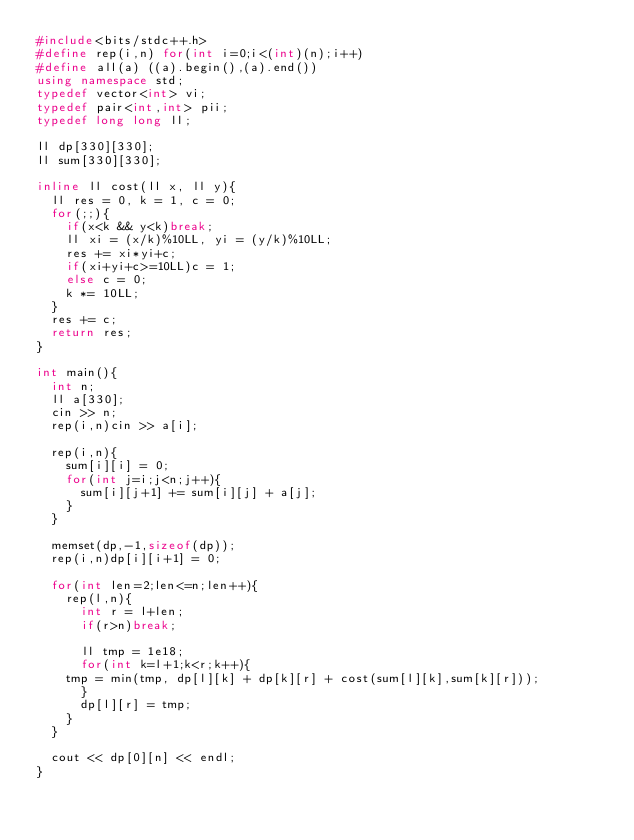<code> <loc_0><loc_0><loc_500><loc_500><_C++_>#include<bits/stdc++.h>
#define rep(i,n) for(int i=0;i<(int)(n);i++)
#define all(a) ((a).begin(),(a).end())
using namespace std;
typedef vector<int> vi;
typedef pair<int,int> pii;
typedef long long ll;

ll dp[330][330];
ll sum[330][330];

inline ll cost(ll x, ll y){
  ll res = 0, k = 1, c = 0;
  for(;;){
    if(x<k && y<k)break;
    ll xi = (x/k)%10LL, yi = (y/k)%10LL;
    res += xi*yi+c;
    if(xi+yi+c>=10LL)c = 1;
    else c = 0;
    k *= 10LL;
  }
  res += c;
  return res;
}

int main(){
  int n;
  ll a[330];
  cin >> n;
  rep(i,n)cin >> a[i];
  
  rep(i,n){
    sum[i][i] = 0;
    for(int j=i;j<n;j++){
      sum[i][j+1] += sum[i][j] + a[j];
    }
  }

  memset(dp,-1,sizeof(dp));
  rep(i,n)dp[i][i+1] = 0;

  for(int len=2;len<=n;len++){
    rep(l,n){
      int r = l+len;
      if(r>n)break;

      ll tmp = 1e18;
      for(int k=l+1;k<r;k++){
	tmp = min(tmp, dp[l][k] + dp[k][r] + cost(sum[l][k],sum[k][r]));
      }
      dp[l][r] = tmp;
    }
  }

  cout << dp[0][n] << endl;
}</code> 